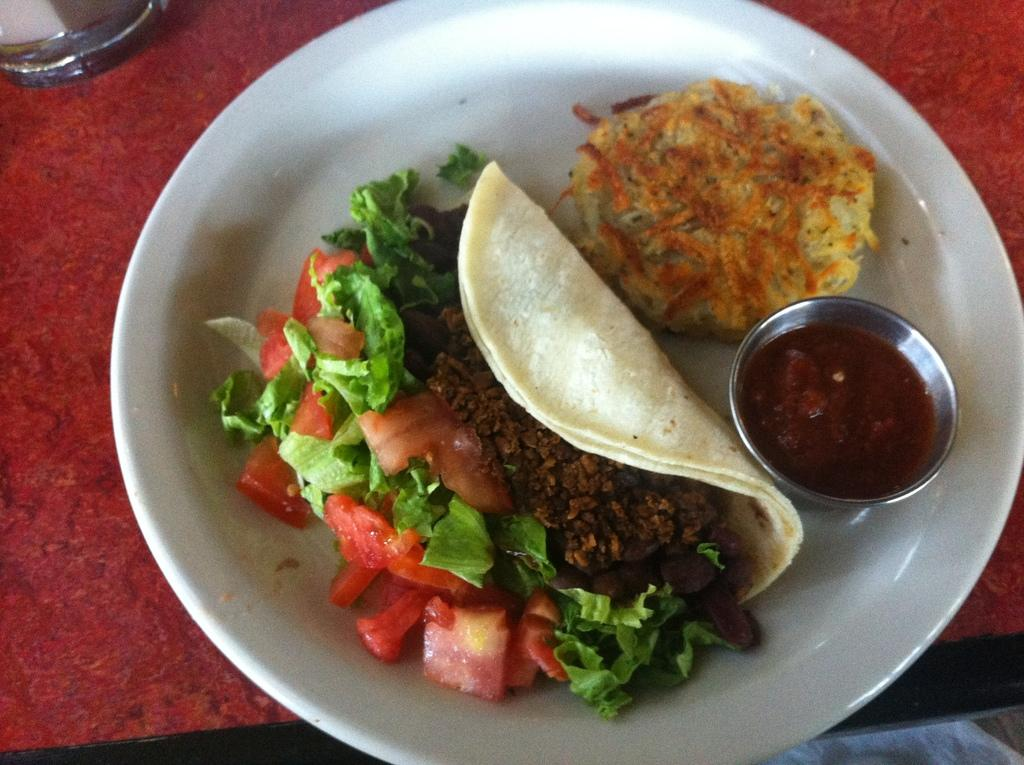What is present on the plate in the image? There are two food items on the plate in the image. Is there any additional element on the plate? Yes, there is sauce served on the plate. What type of hospital can be seen in the background of the image? There is no hospital present in the image; it only features a plate with food items and sauce. 